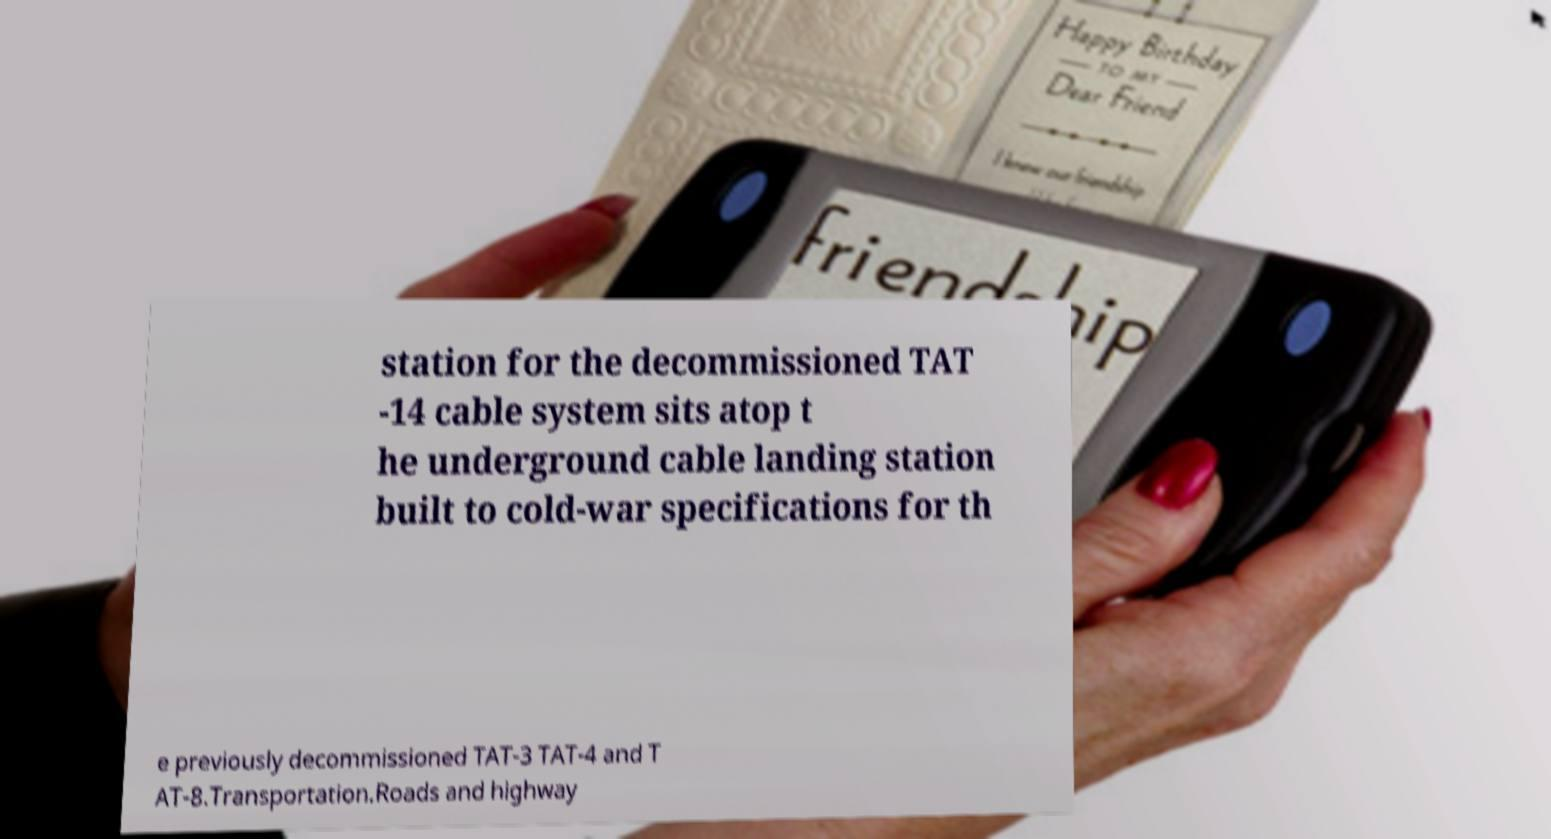For documentation purposes, I need the text within this image transcribed. Could you provide that? station for the decommissioned TAT -14 cable system sits atop t he underground cable landing station built to cold-war specifications for th e previously decommissioned TAT-3 TAT-4 and T AT-8.Transportation.Roads and highway 